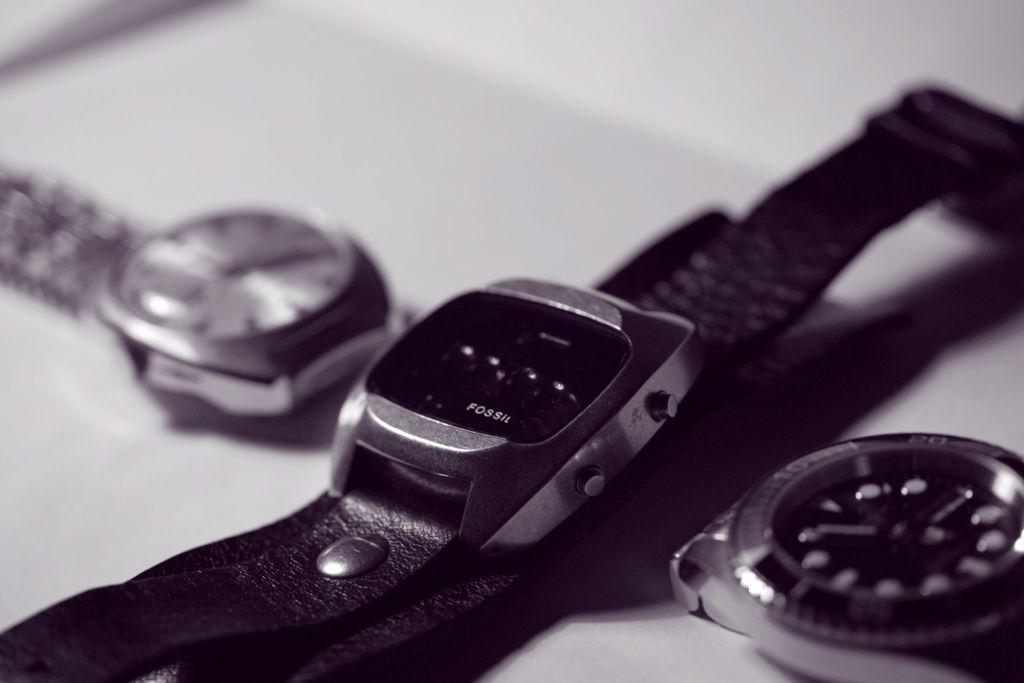Can you describe this image briefly? In this image there are three wrist watches placed on the surface. 